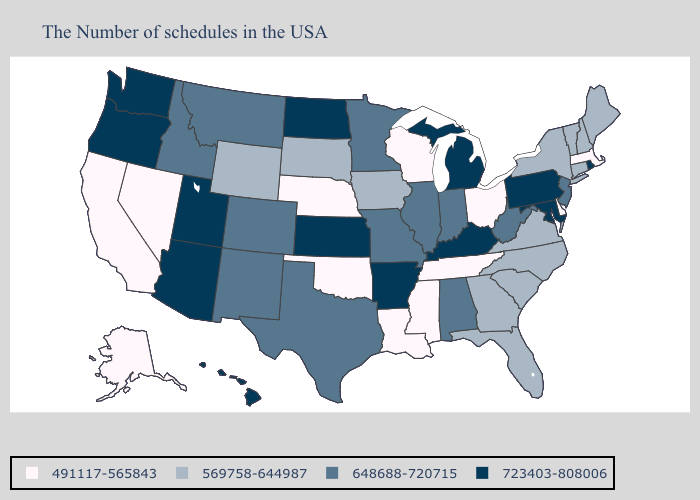What is the value of Michigan?
Be succinct. 723403-808006. Name the states that have a value in the range 723403-808006?
Answer briefly. Rhode Island, Maryland, Pennsylvania, Michigan, Kentucky, Arkansas, Kansas, North Dakota, Utah, Arizona, Washington, Oregon, Hawaii. What is the value of Oklahoma?
Concise answer only. 491117-565843. Does the map have missing data?
Concise answer only. No. What is the value of Minnesota?
Answer briefly. 648688-720715. Name the states that have a value in the range 569758-644987?
Write a very short answer. Maine, New Hampshire, Vermont, Connecticut, New York, Virginia, North Carolina, South Carolina, Florida, Georgia, Iowa, South Dakota, Wyoming. Does Arizona have the lowest value in the USA?
Concise answer only. No. Among the states that border Tennessee , does Arkansas have the highest value?
Short answer required. Yes. What is the value of Kansas?
Be succinct. 723403-808006. What is the value of New Mexico?
Quick response, please. 648688-720715. Which states have the lowest value in the USA?
Answer briefly. Massachusetts, Delaware, Ohio, Tennessee, Wisconsin, Mississippi, Louisiana, Nebraska, Oklahoma, Nevada, California, Alaska. Does the map have missing data?
Quick response, please. No. What is the value of Nevada?
Keep it brief. 491117-565843. What is the highest value in the USA?
Be succinct. 723403-808006. Among the states that border Kentucky , which have the highest value?
Answer briefly. West Virginia, Indiana, Illinois, Missouri. 